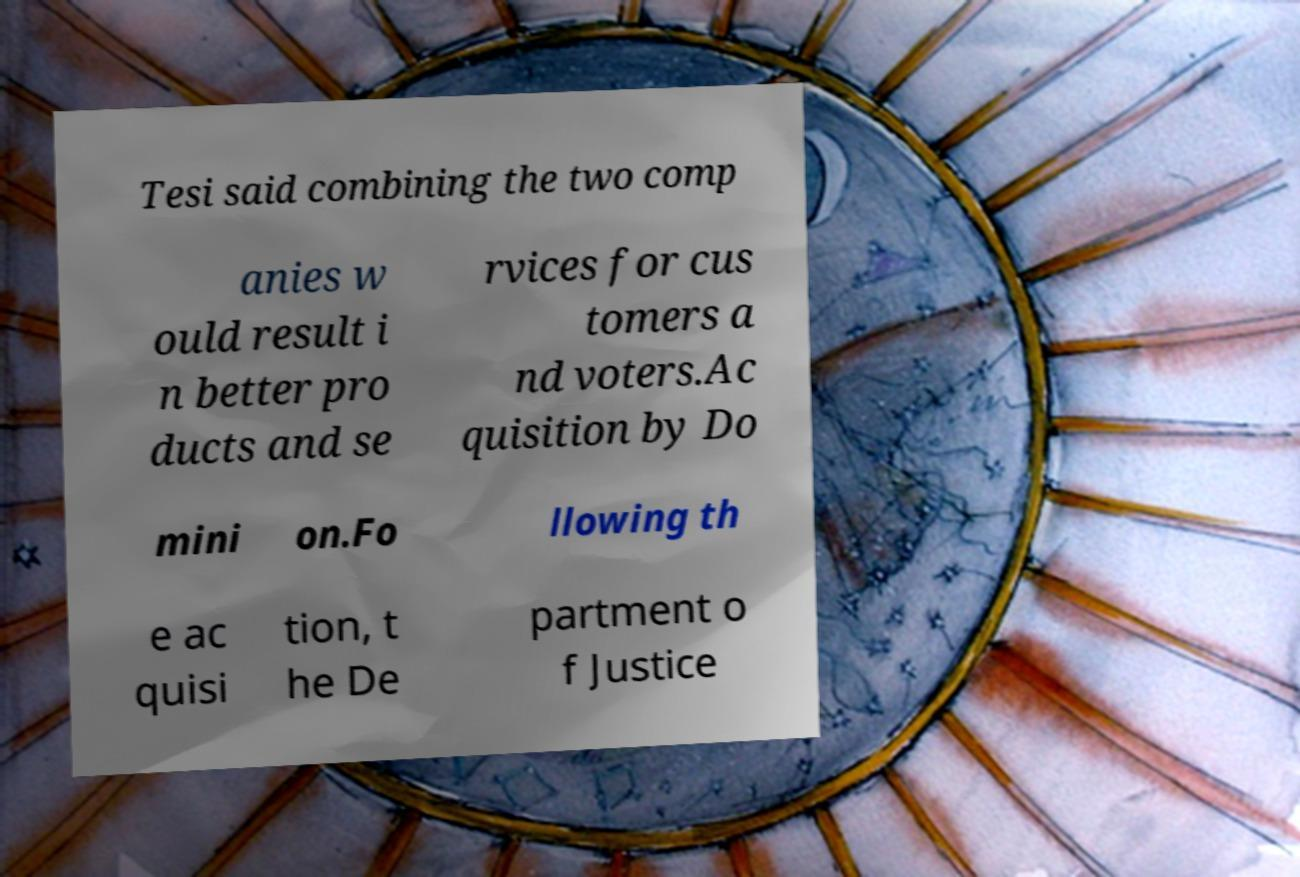Please identify and transcribe the text found in this image. Tesi said combining the two comp anies w ould result i n better pro ducts and se rvices for cus tomers a nd voters.Ac quisition by Do mini on.Fo llowing th e ac quisi tion, t he De partment o f Justice 